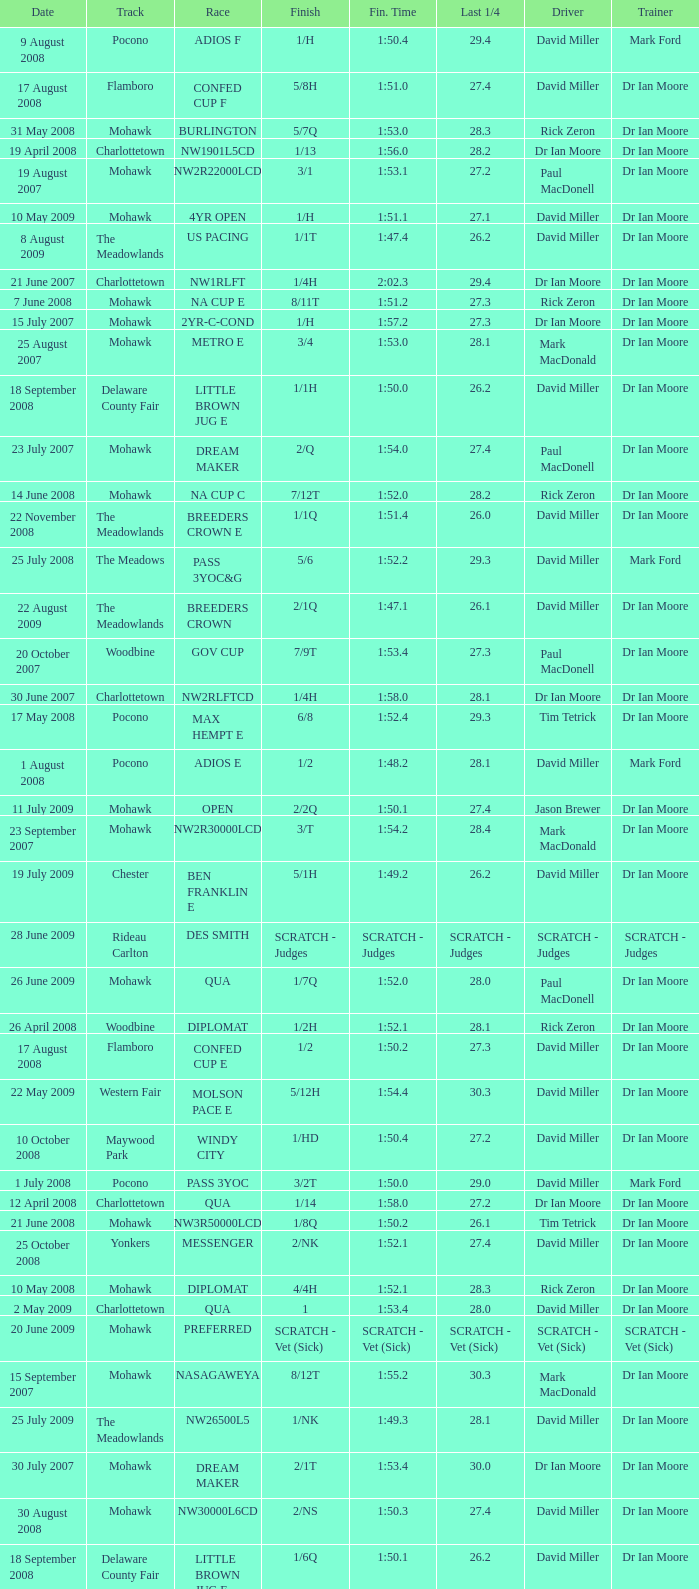What is the finishing time with a 2/1q finish on the Meadowlands track? 1:47.1. 